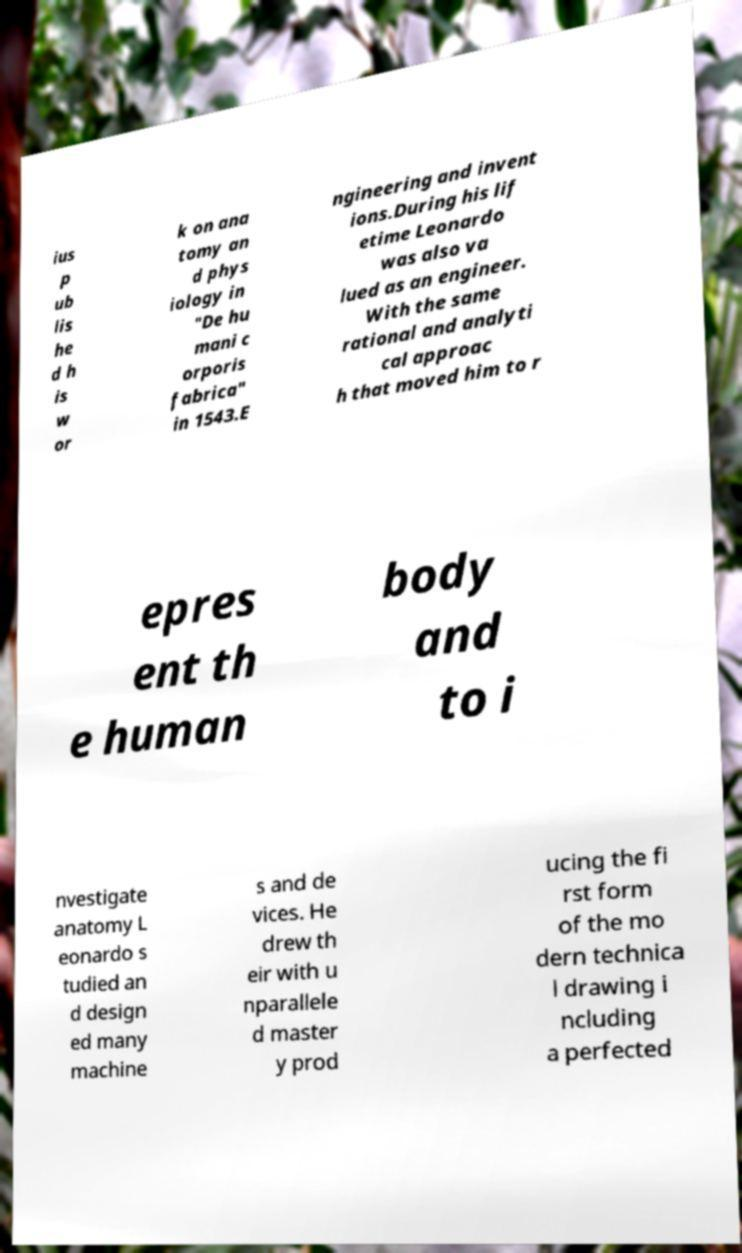Please identify and transcribe the text found in this image. ius p ub lis he d h is w or k on ana tomy an d phys iology in "De hu mani c orporis fabrica" in 1543.E ngineering and invent ions.During his lif etime Leonardo was also va lued as an engineer. With the same rational and analyti cal approac h that moved him to r epres ent th e human body and to i nvestigate anatomy L eonardo s tudied an d design ed many machine s and de vices. He drew th eir with u nparallele d master y prod ucing the fi rst form of the mo dern technica l drawing i ncluding a perfected 